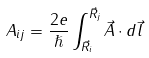<formula> <loc_0><loc_0><loc_500><loc_500>A _ { i j } = \frac { 2 e } { \hslash } \int _ { \vec { R } _ { i } } ^ { \vec { R } _ { j } } \vec { A } \cdot d \vec { l }</formula> 